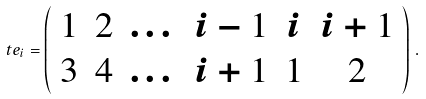<formula> <loc_0><loc_0><loc_500><loc_500>\ t e _ { i } = \left ( \begin{array} { c c c c c c } 1 & 2 & \dots & i - 1 & i & i + 1 \\ 3 & 4 & \dots & i + 1 & 1 & 2 \end{array} \right ) \, .</formula> 